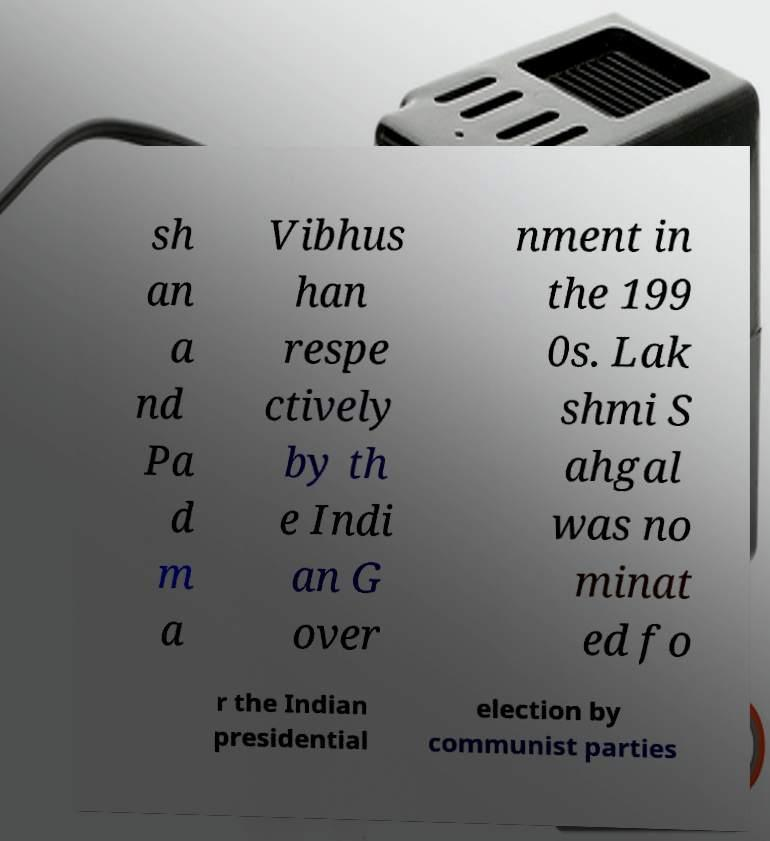Please read and relay the text visible in this image. What does it say? sh an a nd Pa d m a Vibhus han respe ctively by th e Indi an G over nment in the 199 0s. Lak shmi S ahgal was no minat ed fo r the Indian presidential election by communist parties 